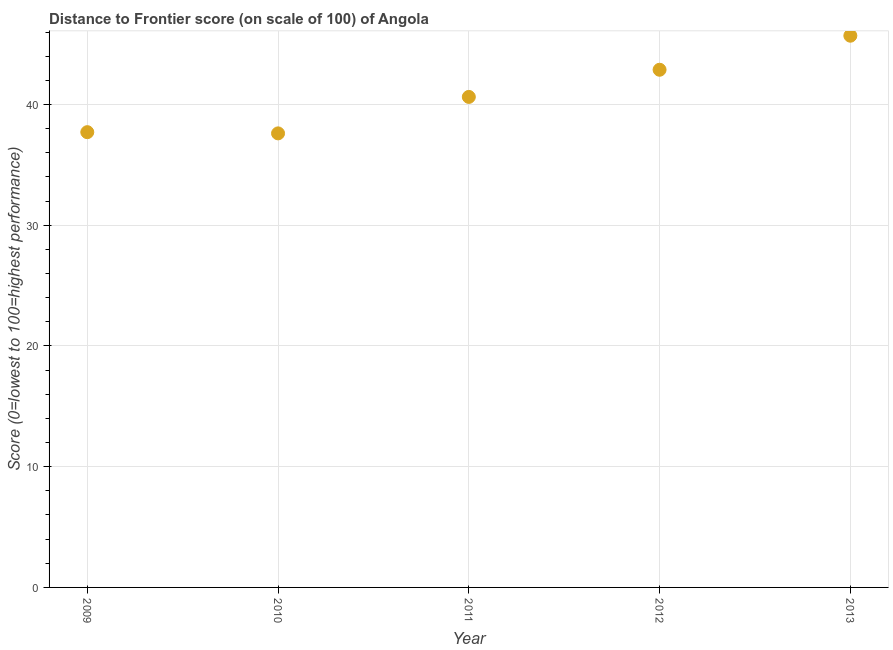What is the distance to frontier score in 2010?
Your answer should be very brief. 37.61. Across all years, what is the maximum distance to frontier score?
Give a very brief answer. 45.7. Across all years, what is the minimum distance to frontier score?
Make the answer very short. 37.61. In which year was the distance to frontier score maximum?
Make the answer very short. 2013. In which year was the distance to frontier score minimum?
Your response must be concise. 2010. What is the sum of the distance to frontier score?
Your answer should be very brief. 204.53. What is the difference between the distance to frontier score in 2010 and 2012?
Provide a short and direct response. -5.27. What is the average distance to frontier score per year?
Make the answer very short. 40.91. What is the median distance to frontier score?
Your response must be concise. 40.63. What is the ratio of the distance to frontier score in 2009 to that in 2012?
Provide a short and direct response. 0.88. Is the distance to frontier score in 2012 less than that in 2013?
Your answer should be very brief. Yes. What is the difference between the highest and the second highest distance to frontier score?
Keep it short and to the point. 2.82. Is the sum of the distance to frontier score in 2011 and 2012 greater than the maximum distance to frontier score across all years?
Provide a short and direct response. Yes. What is the difference between the highest and the lowest distance to frontier score?
Make the answer very short. 8.09. Does the distance to frontier score monotonically increase over the years?
Make the answer very short. No. How many dotlines are there?
Your answer should be very brief. 1. How many years are there in the graph?
Offer a very short reply. 5. Are the values on the major ticks of Y-axis written in scientific E-notation?
Offer a very short reply. No. What is the title of the graph?
Your answer should be very brief. Distance to Frontier score (on scale of 100) of Angola. What is the label or title of the X-axis?
Give a very brief answer. Year. What is the label or title of the Y-axis?
Give a very brief answer. Score (0=lowest to 100=highest performance). What is the Score (0=lowest to 100=highest performance) in 2009?
Your response must be concise. 37.71. What is the Score (0=lowest to 100=highest performance) in 2010?
Ensure brevity in your answer.  37.61. What is the Score (0=lowest to 100=highest performance) in 2011?
Keep it short and to the point. 40.63. What is the Score (0=lowest to 100=highest performance) in 2012?
Ensure brevity in your answer.  42.88. What is the Score (0=lowest to 100=highest performance) in 2013?
Offer a very short reply. 45.7. What is the difference between the Score (0=lowest to 100=highest performance) in 2009 and 2011?
Your response must be concise. -2.92. What is the difference between the Score (0=lowest to 100=highest performance) in 2009 and 2012?
Your answer should be compact. -5.17. What is the difference between the Score (0=lowest to 100=highest performance) in 2009 and 2013?
Your response must be concise. -7.99. What is the difference between the Score (0=lowest to 100=highest performance) in 2010 and 2011?
Make the answer very short. -3.02. What is the difference between the Score (0=lowest to 100=highest performance) in 2010 and 2012?
Provide a short and direct response. -5.27. What is the difference between the Score (0=lowest to 100=highest performance) in 2010 and 2013?
Your answer should be compact. -8.09. What is the difference between the Score (0=lowest to 100=highest performance) in 2011 and 2012?
Make the answer very short. -2.25. What is the difference between the Score (0=lowest to 100=highest performance) in 2011 and 2013?
Keep it short and to the point. -5.07. What is the difference between the Score (0=lowest to 100=highest performance) in 2012 and 2013?
Ensure brevity in your answer.  -2.82. What is the ratio of the Score (0=lowest to 100=highest performance) in 2009 to that in 2011?
Provide a succinct answer. 0.93. What is the ratio of the Score (0=lowest to 100=highest performance) in 2009 to that in 2012?
Provide a short and direct response. 0.88. What is the ratio of the Score (0=lowest to 100=highest performance) in 2009 to that in 2013?
Offer a very short reply. 0.82. What is the ratio of the Score (0=lowest to 100=highest performance) in 2010 to that in 2011?
Provide a short and direct response. 0.93. What is the ratio of the Score (0=lowest to 100=highest performance) in 2010 to that in 2012?
Make the answer very short. 0.88. What is the ratio of the Score (0=lowest to 100=highest performance) in 2010 to that in 2013?
Provide a short and direct response. 0.82. What is the ratio of the Score (0=lowest to 100=highest performance) in 2011 to that in 2012?
Provide a succinct answer. 0.95. What is the ratio of the Score (0=lowest to 100=highest performance) in 2011 to that in 2013?
Ensure brevity in your answer.  0.89. What is the ratio of the Score (0=lowest to 100=highest performance) in 2012 to that in 2013?
Your answer should be compact. 0.94. 